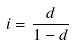Convert formula to latex. <formula><loc_0><loc_0><loc_500><loc_500>i = \frac { d } { 1 - d }</formula> 